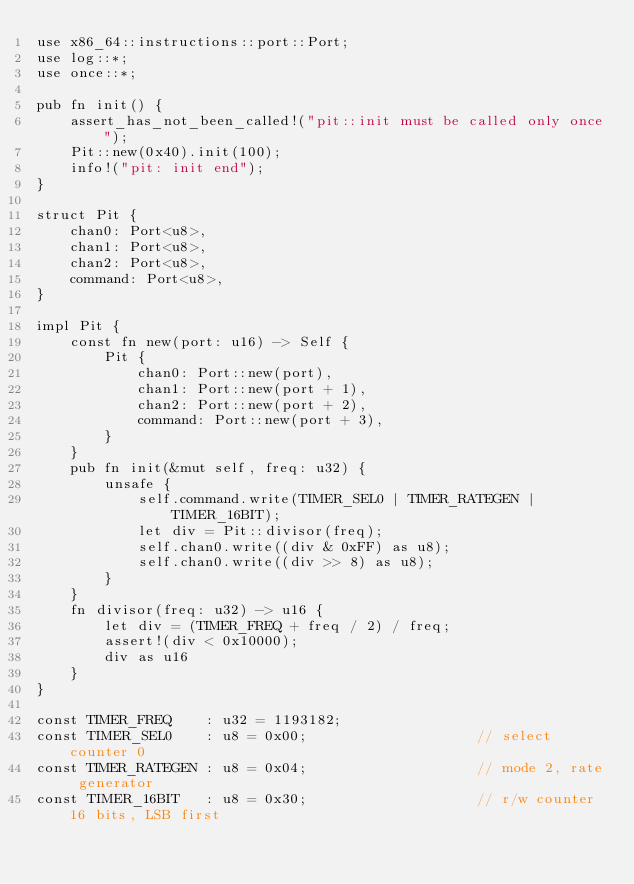<code> <loc_0><loc_0><loc_500><loc_500><_Rust_>use x86_64::instructions::port::Port;
use log::*;
use once::*;

pub fn init() {
    assert_has_not_been_called!("pit::init must be called only once");
    Pit::new(0x40).init(100);
    info!("pit: init end");
}

struct Pit {
    chan0: Port<u8>,
    chan1: Port<u8>,
    chan2: Port<u8>,
    command: Port<u8>,
}

impl Pit {
    const fn new(port: u16) -> Self {
        Pit {
            chan0: Port::new(port),
            chan1: Port::new(port + 1),
            chan2: Port::new(port + 2),
            command: Port::new(port + 3),
        }
    }
    pub fn init(&mut self, freq: u32) {
        unsafe {
            self.command.write(TIMER_SEL0 | TIMER_RATEGEN | TIMER_16BIT);
            let div = Pit::divisor(freq);
            self.chan0.write((div & 0xFF) as u8);
            self.chan0.write((div >> 8) as u8);
        }
    }
    fn divisor(freq: u32) -> u16 {
        let div = (TIMER_FREQ + freq / 2) / freq;
        assert!(div < 0x10000);
        div as u16
    }
}

const TIMER_FREQ    : u32 = 1193182;
const TIMER_SEL0    : u8 = 0x00;                    // select counter 0
const TIMER_RATEGEN : u8 = 0x04;                    // mode 2, rate generator
const TIMER_16BIT   : u8 = 0x30;                    // r/w counter 16 bits, LSB first</code> 